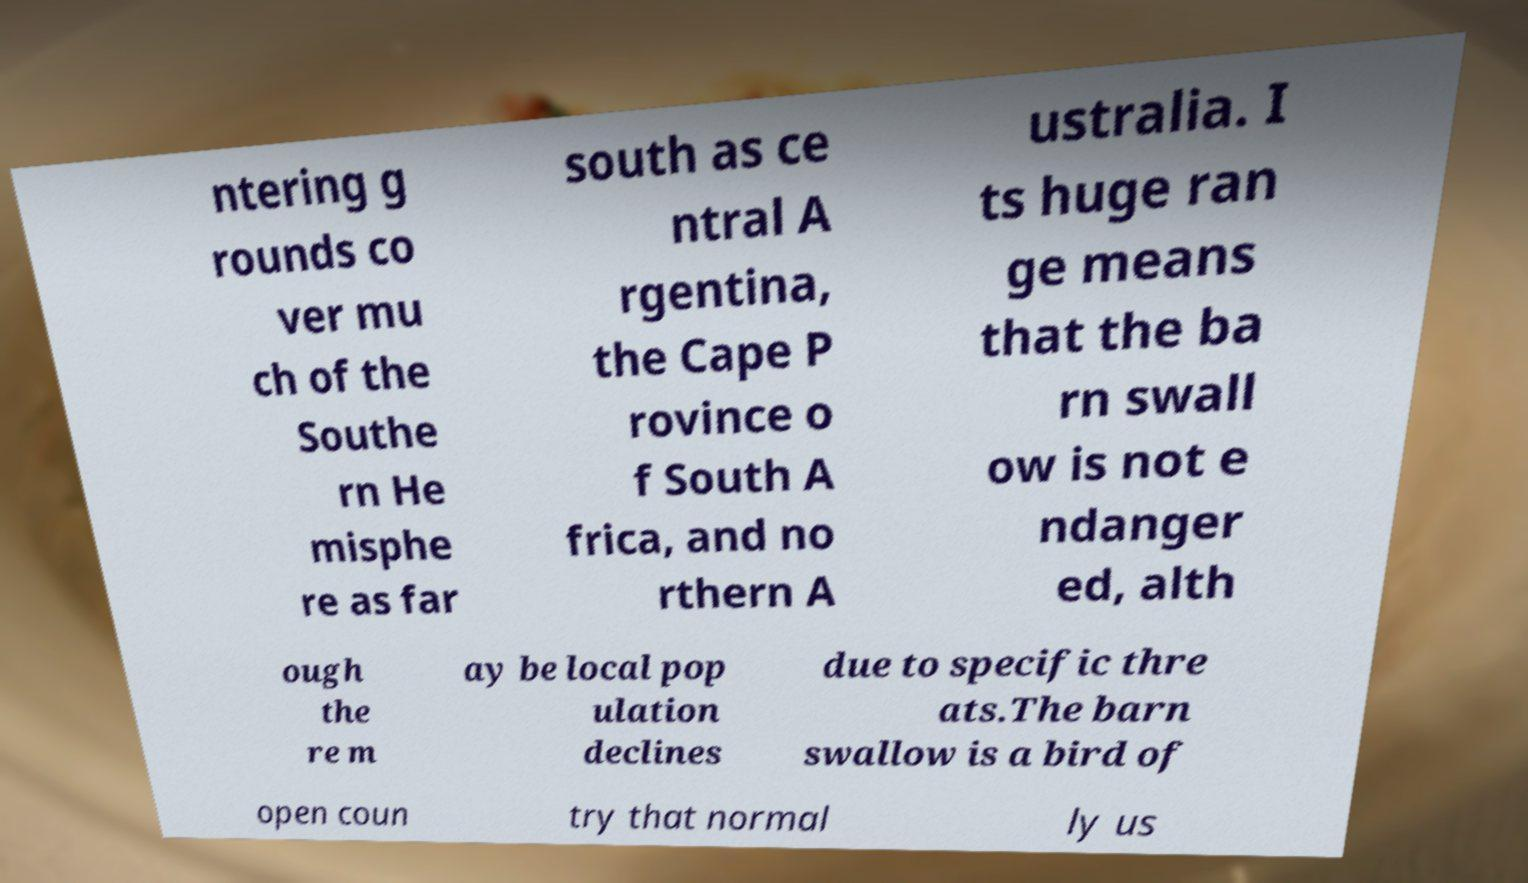For documentation purposes, I need the text within this image transcribed. Could you provide that? ntering g rounds co ver mu ch of the Southe rn He misphe re as far south as ce ntral A rgentina, the Cape P rovince o f South A frica, and no rthern A ustralia. I ts huge ran ge means that the ba rn swall ow is not e ndanger ed, alth ough the re m ay be local pop ulation declines due to specific thre ats.The barn swallow is a bird of open coun try that normal ly us 